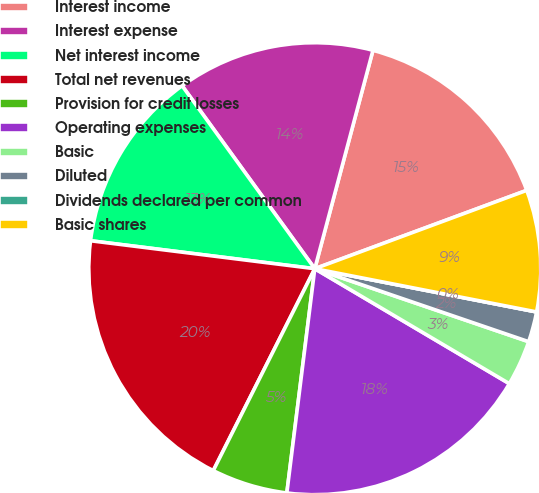Convert chart. <chart><loc_0><loc_0><loc_500><loc_500><pie_chart><fcel>Interest income<fcel>Interest expense<fcel>Net interest income<fcel>Total net revenues<fcel>Provision for credit losses<fcel>Operating expenses<fcel>Basic<fcel>Diluted<fcel>Dividends declared per common<fcel>Basic shares<nl><fcel>15.22%<fcel>14.13%<fcel>13.04%<fcel>19.56%<fcel>5.44%<fcel>18.48%<fcel>3.26%<fcel>2.17%<fcel>0.0%<fcel>8.7%<nl></chart> 